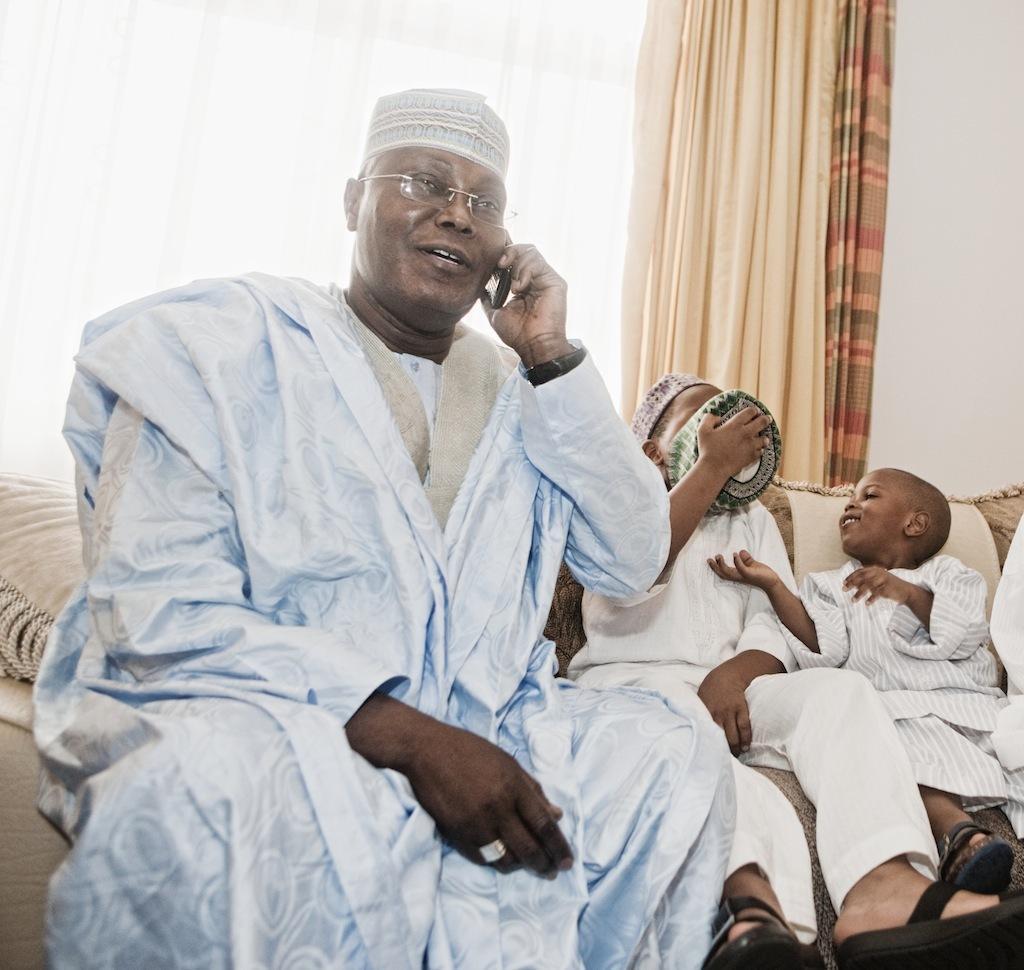In one or two sentences, can you explain what this image depicts? This person and children are sitting on the couch. This person is holding a mobile near his ear. Backside of this person we can see a window and curtains. This is wall. This boy is holding a hat. 